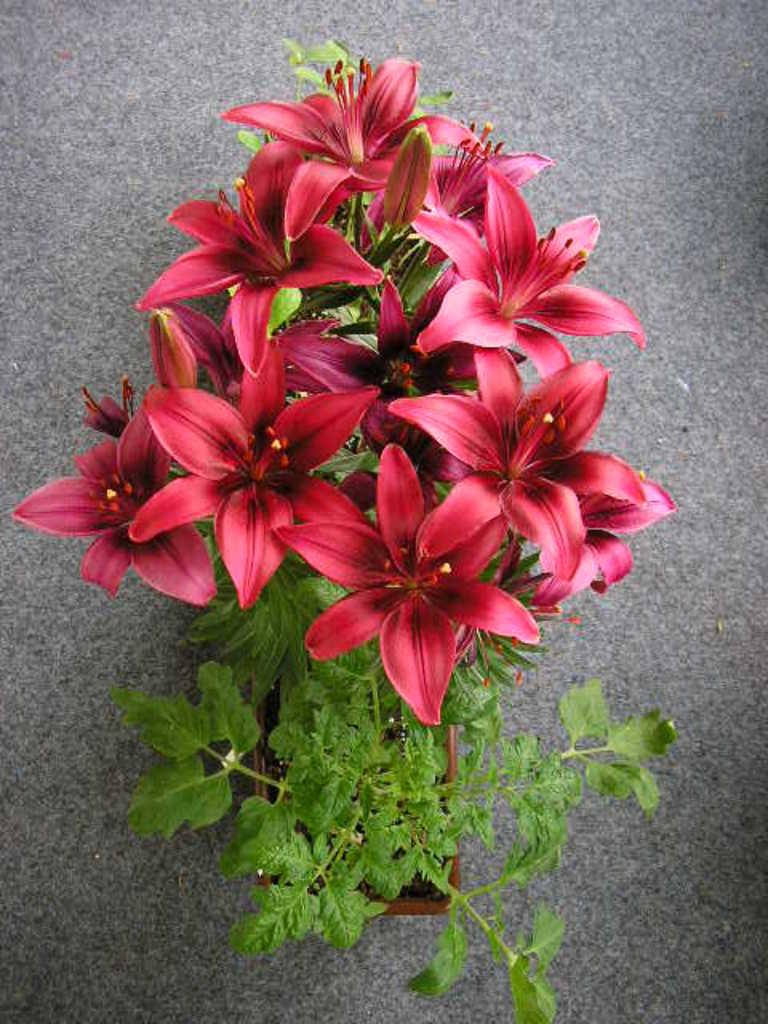What type of plant is visible in the image? There is a flower plant in the image. What type of pies are being baked in the image? There are no pies or baking activity present in the image; it features a flower plant. What season is depicted in the image? The image does not depict a specific season, as there is no indication of weather or time of year. 